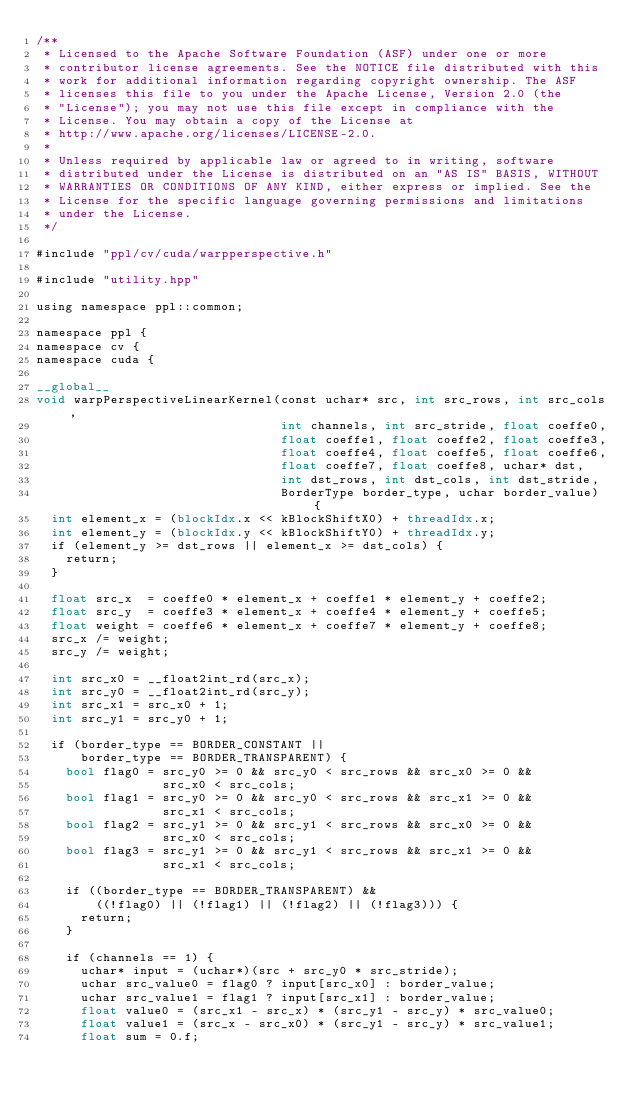Convert code to text. <code><loc_0><loc_0><loc_500><loc_500><_Cuda_>/**
 * Licensed to the Apache Software Foundation (ASF) under one or more
 * contributor license agreements. See the NOTICE file distributed with this
 * work for additional information regarding copyright ownership. The ASF
 * licenses this file to you under the Apache License, Version 2.0 (the
 * "License"); you may not use this file except in compliance with the
 * License. You may obtain a copy of the License at
 * http://www.apache.org/licenses/LICENSE-2.0.
 *
 * Unless required by applicable law or agreed to in writing, software
 * distributed under the License is distributed on an "AS IS" BASIS, WITHOUT
 * WARRANTIES OR CONDITIONS OF ANY KIND, either express or implied. See the
 * License for the specific language governing permissions and limitations
 * under the License.
 */

#include "ppl/cv/cuda/warpperspective.h"

#include "utility.hpp"

using namespace ppl::common;

namespace ppl {
namespace cv {
namespace cuda {

__global__
void warpPerspectiveLinearKernel(const uchar* src, int src_rows, int src_cols,
                                 int channels, int src_stride, float coeffe0,
                                 float coeffe1, float coeffe2, float coeffe3,
                                 float coeffe4, float coeffe5, float coeffe6,
                                 float coeffe7, float coeffe8, uchar* dst,
                                 int dst_rows, int dst_cols, int dst_stride,
                                 BorderType border_type, uchar border_value) {
  int element_x = (blockIdx.x << kBlockShiftX0) + threadIdx.x;
  int element_y = (blockIdx.y << kBlockShiftY0) + threadIdx.y;
  if (element_y >= dst_rows || element_x >= dst_cols) {
    return;
  }

  float src_x  = coeffe0 * element_x + coeffe1 * element_y + coeffe2;
  float src_y  = coeffe3 * element_x + coeffe4 * element_y + coeffe5;
  float weight = coeffe6 * element_x + coeffe7 * element_y + coeffe8;
  src_x /= weight;
  src_y /= weight;

  int src_x0 = __float2int_rd(src_x);
  int src_y0 = __float2int_rd(src_y);
  int src_x1 = src_x0 + 1;
  int src_y1 = src_y0 + 1;

  if (border_type == BORDER_CONSTANT ||
      border_type == BORDER_TRANSPARENT) {
    bool flag0 = src_y0 >= 0 && src_y0 < src_rows && src_x0 >= 0 &&
                 src_x0 < src_cols;
    bool flag1 = src_y0 >= 0 && src_y0 < src_rows && src_x1 >= 0 &&
                 src_x1 < src_cols;
    bool flag2 = src_y1 >= 0 && src_y1 < src_rows && src_x0 >= 0 &&
                 src_x0 < src_cols;
    bool flag3 = src_y1 >= 0 && src_y1 < src_rows && src_x1 >= 0 &&
                 src_x1 < src_cols;

    if ((border_type == BORDER_TRANSPARENT) &&
        ((!flag0) || (!flag1) || (!flag2) || (!flag3))) {
      return;
    }

    if (channels == 1) {
      uchar* input = (uchar*)(src + src_y0 * src_stride);
      uchar src_value0 = flag0 ? input[src_x0] : border_value;
      uchar src_value1 = flag1 ? input[src_x1] : border_value;
      float value0 = (src_x1 - src_x) * (src_y1 - src_y) * src_value0;
      float value1 = (src_x - src_x0) * (src_y1 - src_y) * src_value1;
      float sum = 0.f;</code> 